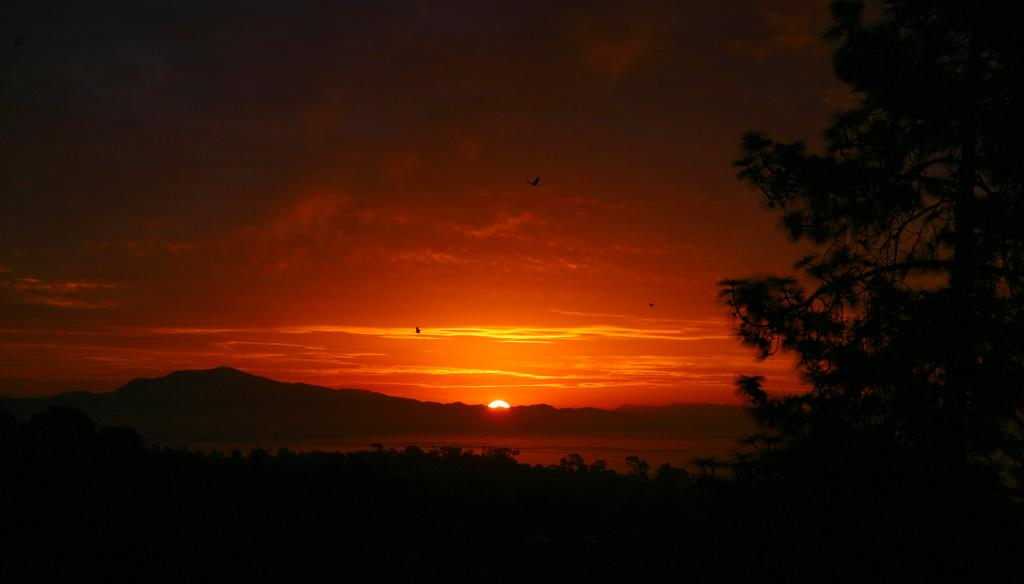What type of vegetation can be seen in the image? There are trees in the image. What natural feature is visible in the background of the image? There are mountains in the background of the image. What animals are present in the image? Birds are flying in the image. What is visible at the top of the image? The sky is visible at the top of the image. What is the source of light in the image? Sunlight is present in the image. Can you see any veins in the image? There are no veins present in the image; it features natural elements such as trees, mountains, and birds. What type of destruction is depicted in the image? There is no destruction present in the image; it showcases natural elements in a peaceful setting. 